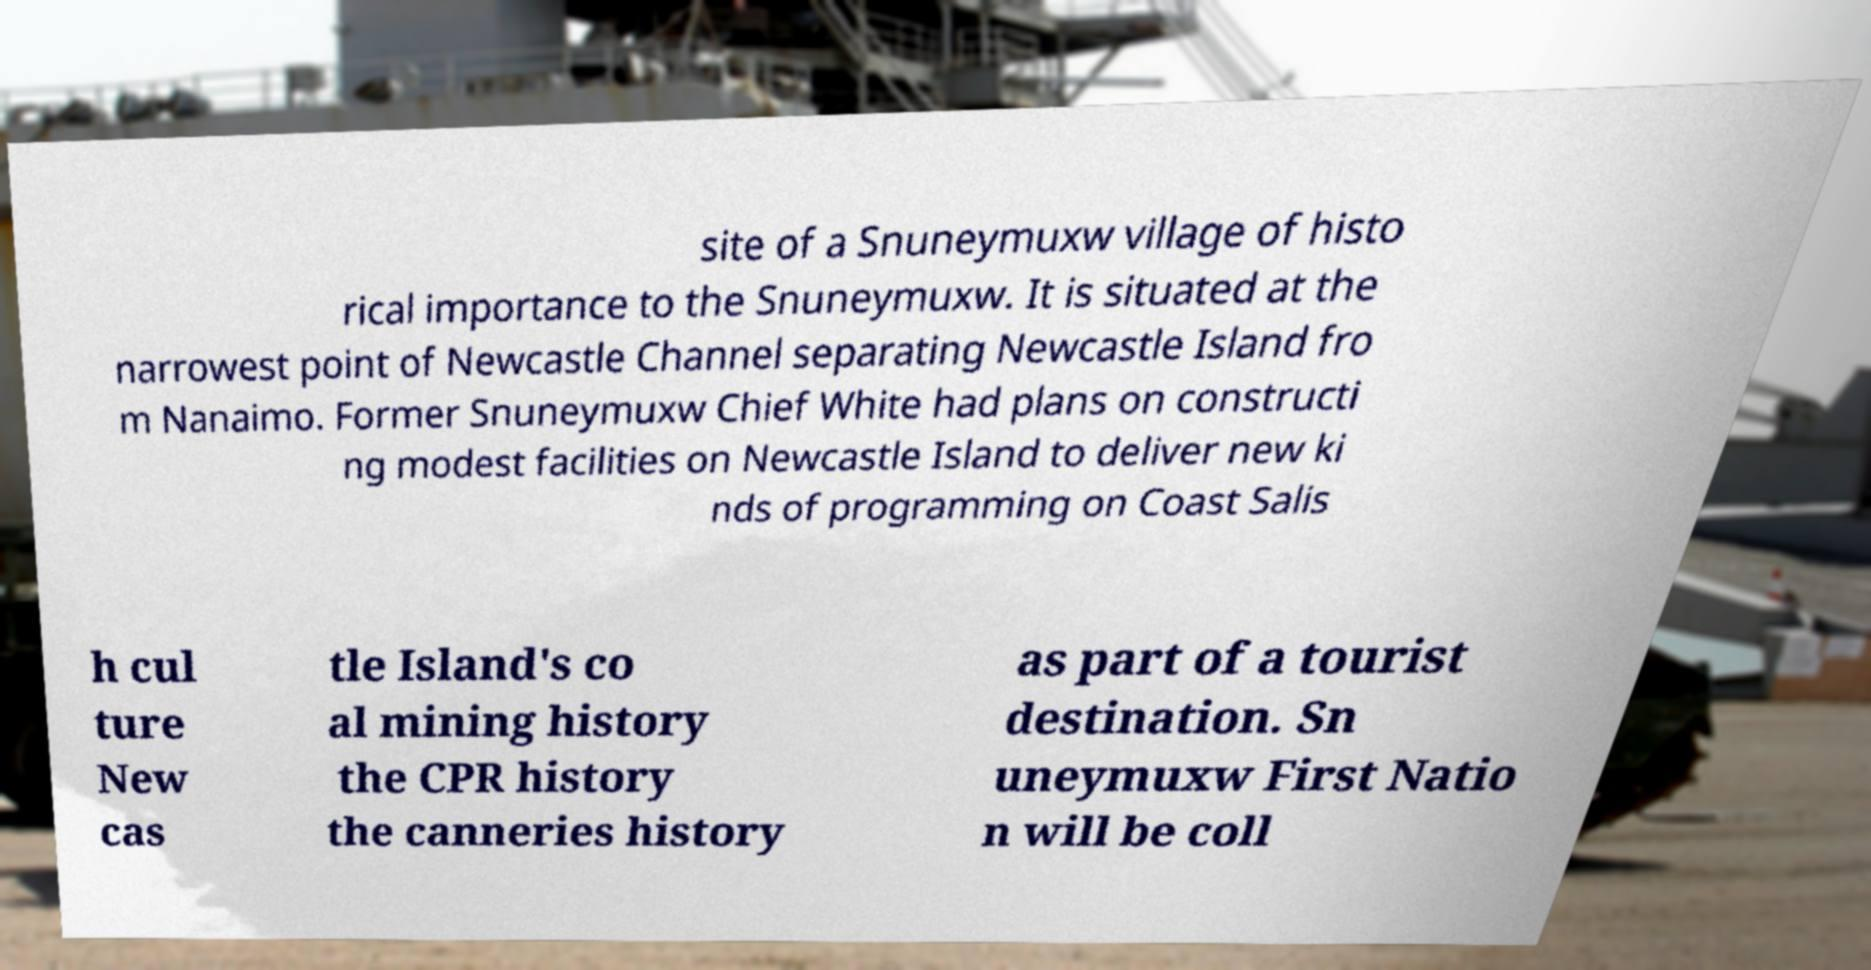Can you read and provide the text displayed in the image?This photo seems to have some interesting text. Can you extract and type it out for me? site of a Snuneymuxw village of histo rical importance to the Snuneymuxw. It is situated at the narrowest point of Newcastle Channel separating Newcastle Island fro m Nanaimo. Former Snuneymuxw Chief White had plans on constructi ng modest facilities on Newcastle Island to deliver new ki nds of programming on Coast Salis h cul ture New cas tle Island's co al mining history the CPR history the canneries history as part of a tourist destination. Sn uneymuxw First Natio n will be coll 